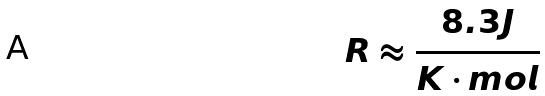<formula> <loc_0><loc_0><loc_500><loc_500>R \approx \frac { 8 . 3 J } { K \cdot m o l }</formula> 